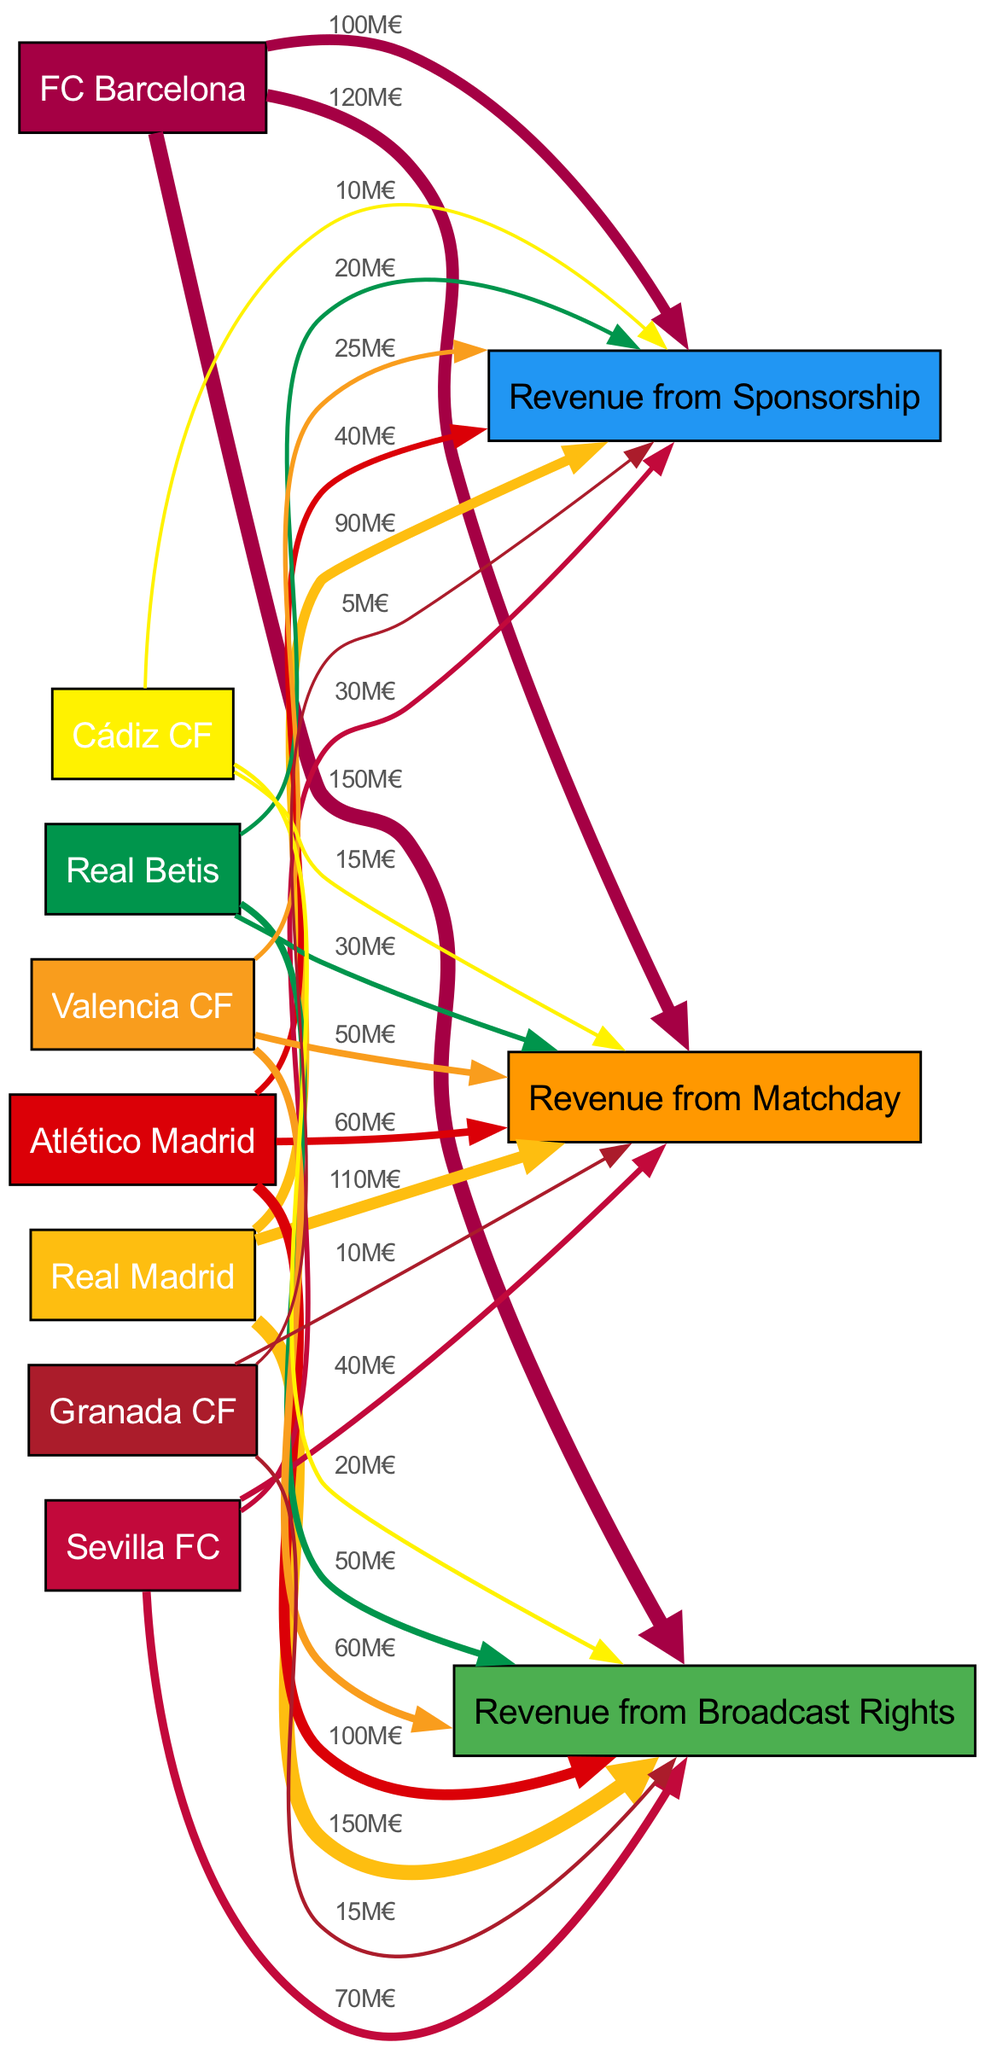What is the total revenue from Broadcast Rights for FC Barcelona? The diagram shows that the revenue link from FC Barcelona to Revenue from Broadcast Rights has a value of 150 million euros.
Answer: 150M€ Which team has the highest revenue from Sponsorship? By looking at the Sponsorship revenue links, we see that the link from FC Barcelona shows a value of 100 million euros, which is higher than the other clubs.
Answer: FC Barcelona How much revenue does Real Madrid generate from Matchday? The diagram indicates that Real Madrid has a link to Revenue from Matchday with a value of 110 million euros.
Answer: 110M€ Which two clubs receive exactly 20 million euros from Broadcast Rights? Both Cádiz CF and Granada CF have links from Broadcast Rights showing the value of 20 million euros each.
Answer: Cádiz CF and Granada CF How many clubs in the diagram have revenue values from Sponsorship? There are a total of 7 clubs having links to Revenue from Sponsorship with specified values.
Answer: 7 Which team has the most disparity in revenue compared to lower-tier teams? By examining the values for the top clubs like FC Barcelona and Real Madrid against lower-tier teams like Cádiz CF and Granada CF, it's clear that FC Barcelona shows the largest disparity with values significantly higher than 20 million euros compared to the lowest.
Answer: FC Barcelona What is the total revenue from Matchday across all clubs? To derive the total revenue from Matchday, add the values from all clubs' links to Revenue from Matchday, yielding the sum of all the individual amounts listed.
Answer: 445M€ Which two sources of revenue does Real Betis rely on the most? Analyzing the links for Real Betis, we find that their revenue from Broadcast Rights (50 million euros) and Matchday (30 million euros) are the two highest.
Answer: Broadcast Rights and Matchday What is the combined revenue from Matchday for Cádiz CF and Granada CF? To find this, we add the values from the links for both teams under Revenue from Matchday, which are 15 million euros for Cádiz CF and 10 million euros for Granada CF. The total is 25 million euros.
Answer: 25M€ 